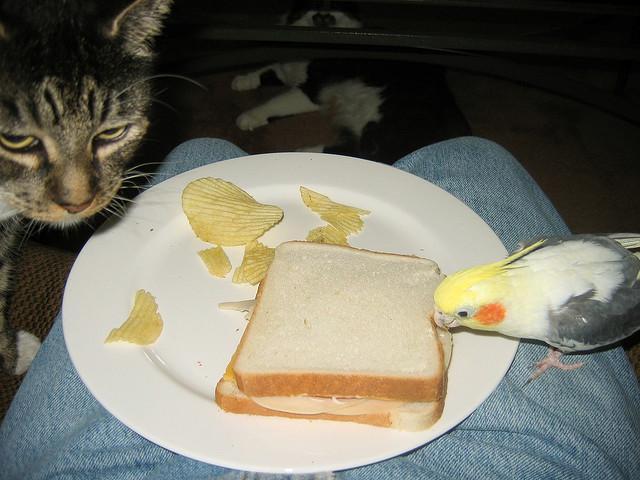How many cats can you see?
Give a very brief answer. 2. How many boats are in the background?
Give a very brief answer. 0. 